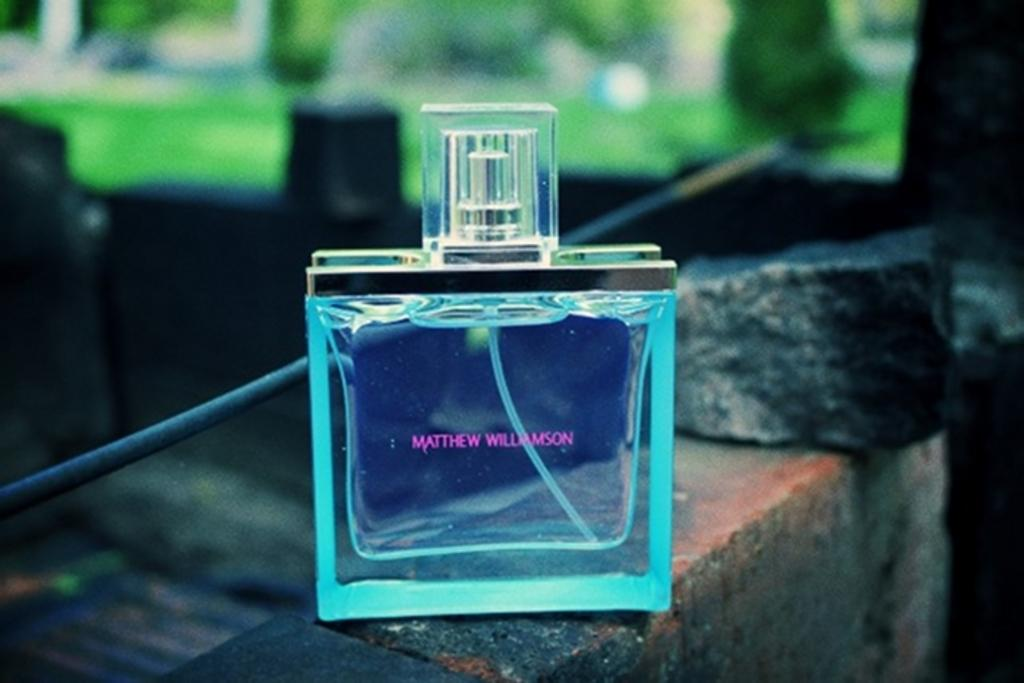<image>
Give a short and clear explanation of the subsequent image. Bottle of Matthew Williamson perfume that is sitting on bricks 